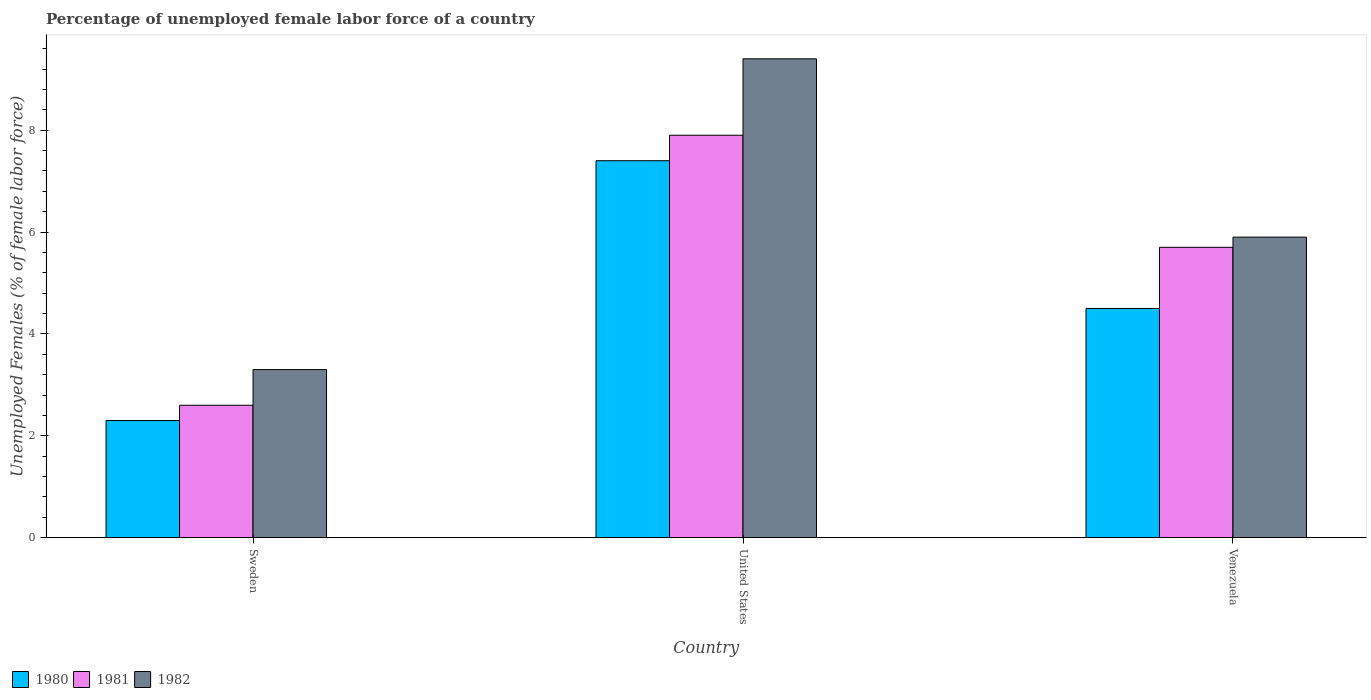How many groups of bars are there?
Keep it short and to the point. 3. Are the number of bars per tick equal to the number of legend labels?
Offer a terse response. Yes. How many bars are there on the 3rd tick from the left?
Offer a terse response. 3. What is the label of the 3rd group of bars from the left?
Ensure brevity in your answer.  Venezuela. What is the percentage of unemployed female labor force in 1981 in Venezuela?
Provide a succinct answer. 5.7. Across all countries, what is the maximum percentage of unemployed female labor force in 1981?
Keep it short and to the point. 7.9. Across all countries, what is the minimum percentage of unemployed female labor force in 1982?
Offer a terse response. 3.3. In which country was the percentage of unemployed female labor force in 1980 minimum?
Provide a short and direct response. Sweden. What is the total percentage of unemployed female labor force in 1980 in the graph?
Ensure brevity in your answer.  14.2. What is the difference between the percentage of unemployed female labor force in 1980 in Sweden and that in Venezuela?
Make the answer very short. -2.2. What is the difference between the percentage of unemployed female labor force in 1981 in Sweden and the percentage of unemployed female labor force in 1982 in United States?
Provide a short and direct response. -6.8. What is the average percentage of unemployed female labor force in 1981 per country?
Give a very brief answer. 5.4. What is the difference between the percentage of unemployed female labor force of/in 1981 and percentage of unemployed female labor force of/in 1980 in Sweden?
Your answer should be compact. 0.3. In how many countries, is the percentage of unemployed female labor force in 1980 greater than 1.2000000000000002 %?
Give a very brief answer. 3. What is the ratio of the percentage of unemployed female labor force in 1981 in Sweden to that in Venezuela?
Ensure brevity in your answer.  0.46. Is the difference between the percentage of unemployed female labor force in 1981 in Sweden and Venezuela greater than the difference between the percentage of unemployed female labor force in 1980 in Sweden and Venezuela?
Provide a short and direct response. No. What is the difference between the highest and the second highest percentage of unemployed female labor force in 1980?
Your answer should be very brief. -2.2. What is the difference between the highest and the lowest percentage of unemployed female labor force in 1982?
Give a very brief answer. 6.1. Is the sum of the percentage of unemployed female labor force in 1980 in Sweden and United States greater than the maximum percentage of unemployed female labor force in 1982 across all countries?
Give a very brief answer. Yes. What does the 1st bar from the left in Venezuela represents?
Your answer should be compact. 1980. What does the 1st bar from the right in Sweden represents?
Offer a very short reply. 1982. Is it the case that in every country, the sum of the percentage of unemployed female labor force in 1982 and percentage of unemployed female labor force in 1981 is greater than the percentage of unemployed female labor force in 1980?
Your response must be concise. Yes. Are all the bars in the graph horizontal?
Your response must be concise. No. How many countries are there in the graph?
Offer a terse response. 3. What is the difference between two consecutive major ticks on the Y-axis?
Ensure brevity in your answer.  2. Are the values on the major ticks of Y-axis written in scientific E-notation?
Your response must be concise. No. Does the graph contain any zero values?
Keep it short and to the point. No. How many legend labels are there?
Give a very brief answer. 3. What is the title of the graph?
Provide a short and direct response. Percentage of unemployed female labor force of a country. Does "1969" appear as one of the legend labels in the graph?
Ensure brevity in your answer.  No. What is the label or title of the X-axis?
Provide a short and direct response. Country. What is the label or title of the Y-axis?
Offer a terse response. Unemployed Females (% of female labor force). What is the Unemployed Females (% of female labor force) of 1980 in Sweden?
Your response must be concise. 2.3. What is the Unemployed Females (% of female labor force) of 1981 in Sweden?
Give a very brief answer. 2.6. What is the Unemployed Females (% of female labor force) of 1982 in Sweden?
Give a very brief answer. 3.3. What is the Unemployed Females (% of female labor force) in 1980 in United States?
Provide a succinct answer. 7.4. What is the Unemployed Females (% of female labor force) in 1981 in United States?
Provide a short and direct response. 7.9. What is the Unemployed Females (% of female labor force) in 1982 in United States?
Offer a terse response. 9.4. What is the Unemployed Females (% of female labor force) in 1981 in Venezuela?
Offer a very short reply. 5.7. What is the Unemployed Females (% of female labor force) of 1982 in Venezuela?
Your response must be concise. 5.9. Across all countries, what is the maximum Unemployed Females (% of female labor force) of 1980?
Give a very brief answer. 7.4. Across all countries, what is the maximum Unemployed Females (% of female labor force) in 1981?
Keep it short and to the point. 7.9. Across all countries, what is the maximum Unemployed Females (% of female labor force) of 1982?
Give a very brief answer. 9.4. Across all countries, what is the minimum Unemployed Females (% of female labor force) in 1980?
Keep it short and to the point. 2.3. Across all countries, what is the minimum Unemployed Females (% of female labor force) in 1981?
Your response must be concise. 2.6. Across all countries, what is the minimum Unemployed Females (% of female labor force) of 1982?
Your answer should be compact. 3.3. What is the total Unemployed Females (% of female labor force) in 1980 in the graph?
Ensure brevity in your answer.  14.2. What is the total Unemployed Females (% of female labor force) of 1981 in the graph?
Offer a terse response. 16.2. What is the difference between the Unemployed Females (% of female labor force) of 1982 in Sweden and that in Venezuela?
Keep it short and to the point. -2.6. What is the difference between the Unemployed Females (% of female labor force) in 1980 in United States and that in Venezuela?
Keep it short and to the point. 2.9. What is the difference between the Unemployed Females (% of female labor force) of 1980 in Sweden and the Unemployed Females (% of female labor force) of 1981 in United States?
Provide a succinct answer. -5.6. What is the difference between the Unemployed Females (% of female labor force) of 1981 in Sweden and the Unemployed Females (% of female labor force) of 1982 in United States?
Your response must be concise. -6.8. What is the difference between the Unemployed Females (% of female labor force) in 1980 in Sweden and the Unemployed Females (% of female labor force) in 1981 in Venezuela?
Provide a short and direct response. -3.4. What is the difference between the Unemployed Females (% of female labor force) of 1980 in United States and the Unemployed Females (% of female labor force) of 1982 in Venezuela?
Offer a terse response. 1.5. What is the average Unemployed Females (% of female labor force) in 1980 per country?
Your answer should be compact. 4.73. What is the difference between the Unemployed Females (% of female labor force) in 1980 and Unemployed Females (% of female labor force) in 1981 in Sweden?
Provide a short and direct response. -0.3. What is the difference between the Unemployed Females (% of female labor force) in 1980 and Unemployed Females (% of female labor force) in 1982 in Sweden?
Provide a short and direct response. -1. What is the difference between the Unemployed Females (% of female labor force) of 1980 and Unemployed Females (% of female labor force) of 1982 in United States?
Make the answer very short. -2. What is the difference between the Unemployed Females (% of female labor force) in 1981 and Unemployed Females (% of female labor force) in 1982 in United States?
Your answer should be compact. -1.5. What is the difference between the Unemployed Females (% of female labor force) in 1980 and Unemployed Females (% of female labor force) in 1981 in Venezuela?
Offer a terse response. -1.2. What is the difference between the Unemployed Females (% of female labor force) of 1981 and Unemployed Females (% of female labor force) of 1982 in Venezuela?
Provide a short and direct response. -0.2. What is the ratio of the Unemployed Females (% of female labor force) in 1980 in Sweden to that in United States?
Provide a short and direct response. 0.31. What is the ratio of the Unemployed Females (% of female labor force) in 1981 in Sweden to that in United States?
Keep it short and to the point. 0.33. What is the ratio of the Unemployed Females (% of female labor force) of 1982 in Sweden to that in United States?
Offer a very short reply. 0.35. What is the ratio of the Unemployed Females (% of female labor force) of 1980 in Sweden to that in Venezuela?
Give a very brief answer. 0.51. What is the ratio of the Unemployed Females (% of female labor force) in 1981 in Sweden to that in Venezuela?
Make the answer very short. 0.46. What is the ratio of the Unemployed Females (% of female labor force) in 1982 in Sweden to that in Venezuela?
Offer a very short reply. 0.56. What is the ratio of the Unemployed Females (% of female labor force) of 1980 in United States to that in Venezuela?
Provide a short and direct response. 1.64. What is the ratio of the Unemployed Females (% of female labor force) of 1981 in United States to that in Venezuela?
Keep it short and to the point. 1.39. What is the ratio of the Unemployed Females (% of female labor force) of 1982 in United States to that in Venezuela?
Provide a short and direct response. 1.59. What is the difference between the highest and the second highest Unemployed Females (% of female labor force) of 1980?
Your answer should be compact. 2.9. What is the difference between the highest and the second highest Unemployed Females (% of female labor force) in 1981?
Offer a terse response. 2.2. What is the difference between the highest and the second highest Unemployed Females (% of female labor force) in 1982?
Your response must be concise. 3.5. What is the difference between the highest and the lowest Unemployed Females (% of female labor force) in 1980?
Your answer should be compact. 5.1. What is the difference between the highest and the lowest Unemployed Females (% of female labor force) of 1981?
Your answer should be compact. 5.3. 